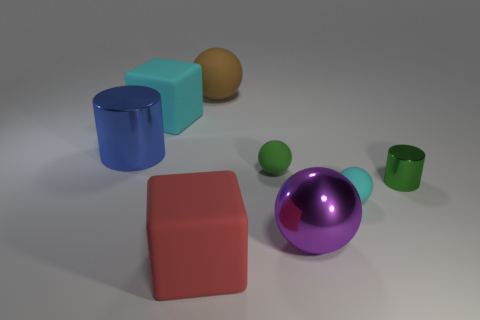There is a cylinder that is on the left side of the metal cylinder that is on the right side of the big matte cube to the left of the large red matte cube; what is its material?
Provide a short and direct response. Metal. What number of spheres are small green objects or large matte objects?
Your response must be concise. 2. There is a green rubber thing that is to the left of the small object that is to the right of the small cyan thing; how many large purple shiny spheres are to the left of it?
Offer a terse response. 0. Is the red object the same shape as the blue object?
Offer a terse response. No. Does the big ball that is behind the cyan ball have the same material as the red object that is on the left side of the brown matte sphere?
Offer a very short reply. Yes. How many things are either cyan rubber things that are behind the blue cylinder or things that are on the right side of the brown rubber thing?
Keep it short and to the point. 5. What number of big red matte things are there?
Offer a terse response. 1. Is there a brown thing of the same size as the blue metallic thing?
Keep it short and to the point. Yes. Is the material of the large brown thing the same as the big sphere that is in front of the small cylinder?
Provide a succinct answer. No. There is a large ball in front of the big blue metallic cylinder; what is it made of?
Keep it short and to the point. Metal. 